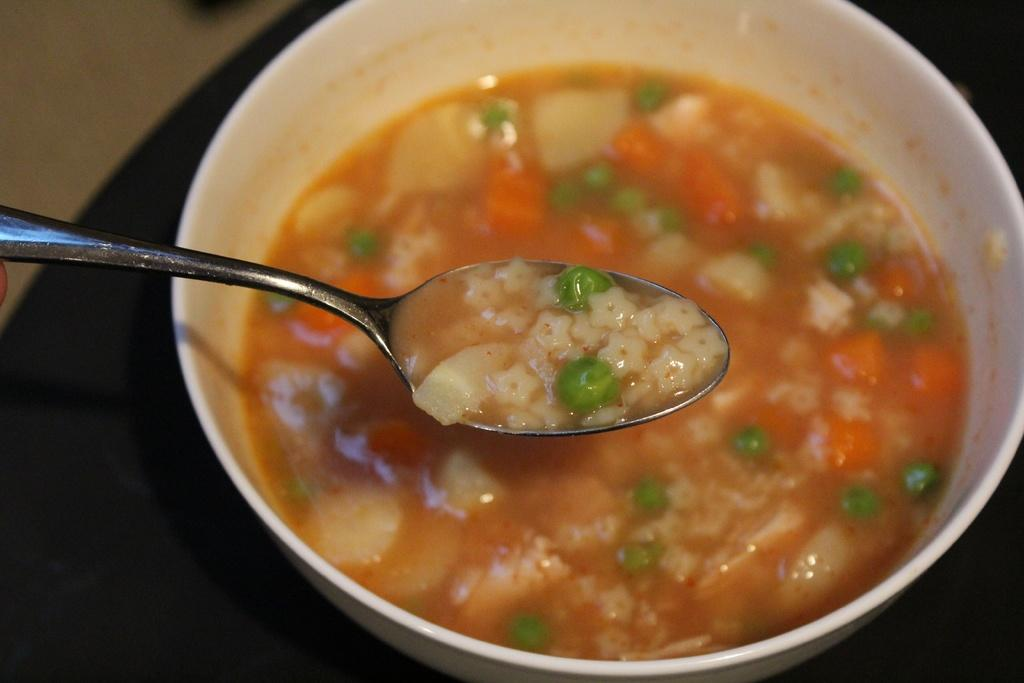What is in the bowl that is visible in the image? There is a bowl with food in the image. What utensil is present in the image? There is a spoon with food in the image. What can be seen beneath the bowl and spoon in the image? The ground is visible in the image. What type of camp can be seen in the background of the image? There is no camp present in the image; it only features a bowl with food, a spoon with food, and the ground. 